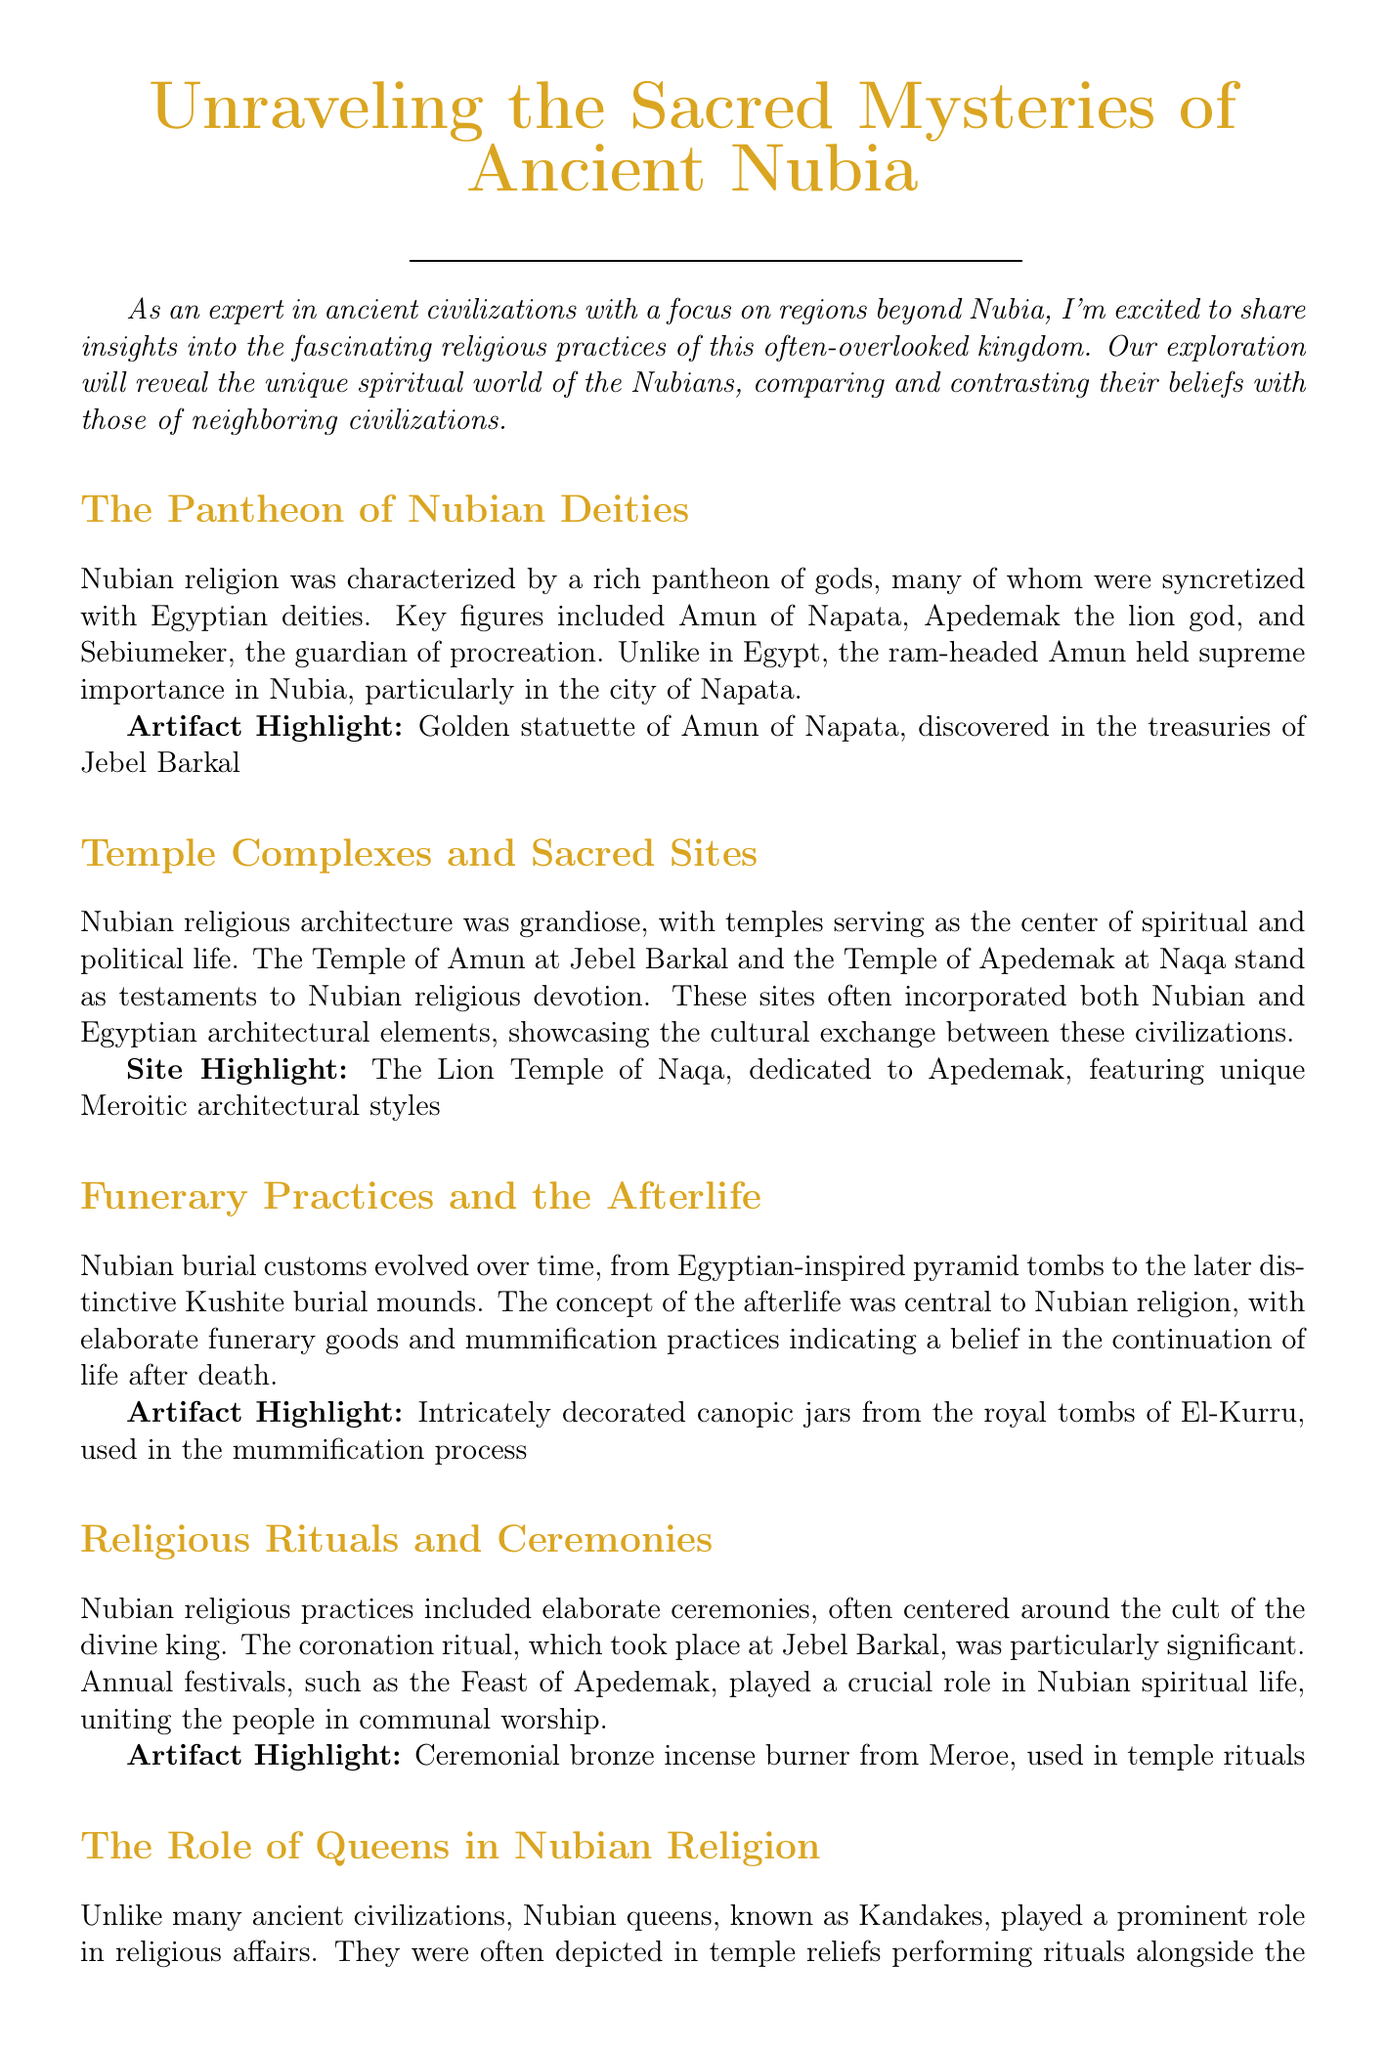What is the title of the newsletter? The title of the newsletter is presented at the top of the document.
Answer: Unraveling the Sacred Mysteries of Ancient Nubia Who is the author of the newsletter? The author's name is mentioned in the author section at the end of the document.
Answer: Dr. Elena Vasquez Which god was of supreme importance in Nubia? The document features a section on Nubian deities discussing their significance.
Answer: Amun of Napata What style of architecture is highlighted in the Lion Temple of Naqa? The architectural style is mentioned in the section on sacred sites.
Answer: Meroitic architectural styles What role did Kandakes play in Nubian religion? The document mentions the involvement of queens in religious affairs.
Answer: Prominent role Which artifact is highlighted in relation to funerary practices? The funerary practices section specifically mentions an artifact.
Answer: Intricately decorated canopic jars When was the coronation ritual significant? The significance of the coronation ritual is noted in the rituals section.
Answer: At Jebel Barkal What is one of the additional resources listed? The document includes a list of resources for further reading.
Answer: The Royal Cemeteries of Kush series by Dows Dunham Which ritual unites the people in Nubian spiritual life? A specific festival is mentioned that plays a key role in communal worship.
Answer: Feast of Apedemak 